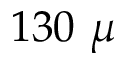Convert formula to latex. <formula><loc_0><loc_0><loc_500><loc_500>1 3 0 \mu</formula> 